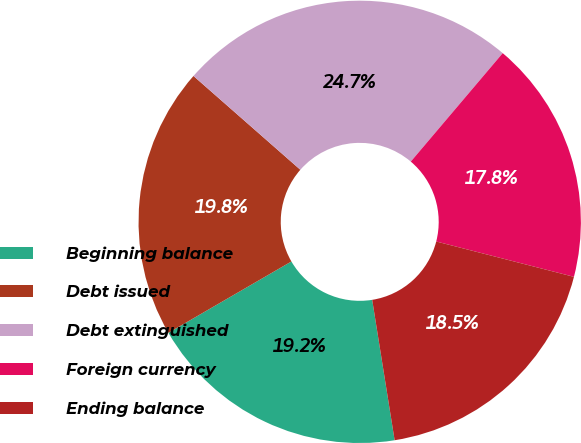Convert chart. <chart><loc_0><loc_0><loc_500><loc_500><pie_chart><fcel>Beginning balance<fcel>Debt issued<fcel>Debt extinguished<fcel>Foreign currency<fcel>Ending balance<nl><fcel>19.16%<fcel>19.83%<fcel>24.73%<fcel>17.81%<fcel>18.48%<nl></chart> 